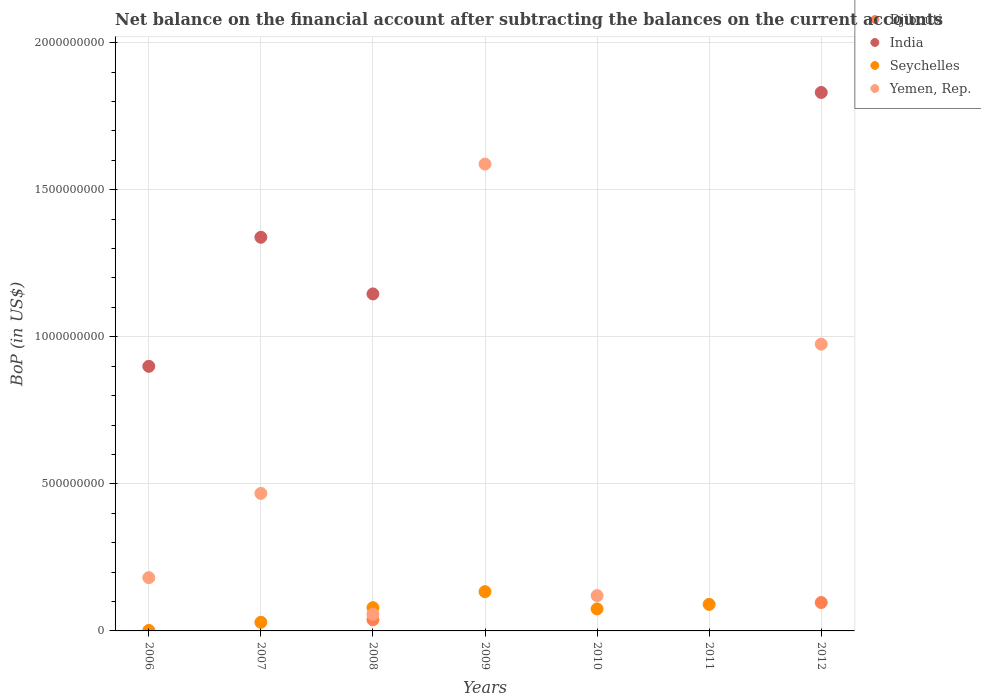What is the Balance of Payments in Djibouti in 2012?
Your answer should be compact. 9.65e+07. Across all years, what is the maximum Balance of Payments in Seychelles?
Your response must be concise. 1.33e+08. Across all years, what is the minimum Balance of Payments in Seychelles?
Your answer should be very brief. 0. What is the total Balance of Payments in India in the graph?
Ensure brevity in your answer.  5.21e+09. What is the difference between the Balance of Payments in Seychelles in 2009 and that in 2011?
Your response must be concise. 4.33e+07. What is the difference between the Balance of Payments in Yemen, Rep. in 2006 and the Balance of Payments in Djibouti in 2007?
Ensure brevity in your answer.  1.81e+08. What is the average Balance of Payments in Djibouti per year?
Give a very brief answer. 1.92e+07. In the year 2009, what is the difference between the Balance of Payments in Seychelles and Balance of Payments in Yemen, Rep.?
Ensure brevity in your answer.  -1.45e+09. In how many years, is the Balance of Payments in Djibouti greater than 100000000 US$?
Make the answer very short. 0. What is the ratio of the Balance of Payments in Seychelles in 2006 to that in 2007?
Offer a terse response. 0.05. Is the difference between the Balance of Payments in Seychelles in 2006 and 2009 greater than the difference between the Balance of Payments in Yemen, Rep. in 2006 and 2009?
Keep it short and to the point. Yes. What is the difference between the highest and the second highest Balance of Payments in Yemen, Rep.?
Ensure brevity in your answer.  6.12e+08. What is the difference between the highest and the lowest Balance of Payments in Seychelles?
Offer a terse response. 1.33e+08. Is it the case that in every year, the sum of the Balance of Payments in Seychelles and Balance of Payments in India  is greater than the Balance of Payments in Djibouti?
Your answer should be very brief. Yes. Is the Balance of Payments in Djibouti strictly less than the Balance of Payments in Seychelles over the years?
Offer a terse response. No. How many dotlines are there?
Provide a short and direct response. 4. What is the difference between two consecutive major ticks on the Y-axis?
Make the answer very short. 5.00e+08. Does the graph contain grids?
Your answer should be compact. Yes. Where does the legend appear in the graph?
Offer a very short reply. Top right. What is the title of the graph?
Ensure brevity in your answer.  Net balance on the financial account after subtracting the balances on the current accounts. What is the label or title of the X-axis?
Ensure brevity in your answer.  Years. What is the label or title of the Y-axis?
Keep it short and to the point. BoP (in US$). What is the BoP (in US$) in India in 2006?
Your answer should be very brief. 9.00e+08. What is the BoP (in US$) in Seychelles in 2006?
Offer a terse response. 1.60e+06. What is the BoP (in US$) of Yemen, Rep. in 2006?
Your answer should be very brief. 1.81e+08. What is the BoP (in US$) of Djibouti in 2007?
Provide a short and direct response. 0. What is the BoP (in US$) of India in 2007?
Your answer should be compact. 1.34e+09. What is the BoP (in US$) of Seychelles in 2007?
Provide a short and direct response. 2.93e+07. What is the BoP (in US$) of Yemen, Rep. in 2007?
Provide a short and direct response. 4.68e+08. What is the BoP (in US$) in Djibouti in 2008?
Your answer should be very brief. 3.79e+07. What is the BoP (in US$) in India in 2008?
Your answer should be compact. 1.15e+09. What is the BoP (in US$) of Seychelles in 2008?
Make the answer very short. 7.90e+07. What is the BoP (in US$) in Yemen, Rep. in 2008?
Make the answer very short. 5.66e+07. What is the BoP (in US$) of India in 2009?
Offer a very short reply. 0. What is the BoP (in US$) of Seychelles in 2009?
Provide a short and direct response. 1.33e+08. What is the BoP (in US$) in Yemen, Rep. in 2009?
Your answer should be very brief. 1.59e+09. What is the BoP (in US$) of India in 2010?
Keep it short and to the point. 0. What is the BoP (in US$) of Seychelles in 2010?
Provide a succinct answer. 7.48e+07. What is the BoP (in US$) in Yemen, Rep. in 2010?
Provide a succinct answer. 1.20e+08. What is the BoP (in US$) of Djibouti in 2011?
Keep it short and to the point. 0. What is the BoP (in US$) of Seychelles in 2011?
Make the answer very short. 9.02e+07. What is the BoP (in US$) of Djibouti in 2012?
Make the answer very short. 9.65e+07. What is the BoP (in US$) of India in 2012?
Ensure brevity in your answer.  1.83e+09. What is the BoP (in US$) of Seychelles in 2012?
Ensure brevity in your answer.  0. What is the BoP (in US$) of Yemen, Rep. in 2012?
Give a very brief answer. 9.75e+08. Across all years, what is the maximum BoP (in US$) of Djibouti?
Keep it short and to the point. 9.65e+07. Across all years, what is the maximum BoP (in US$) in India?
Keep it short and to the point. 1.83e+09. Across all years, what is the maximum BoP (in US$) of Seychelles?
Give a very brief answer. 1.33e+08. Across all years, what is the maximum BoP (in US$) in Yemen, Rep.?
Ensure brevity in your answer.  1.59e+09. Across all years, what is the minimum BoP (in US$) in India?
Provide a succinct answer. 0. Across all years, what is the minimum BoP (in US$) in Yemen, Rep.?
Offer a very short reply. 0. What is the total BoP (in US$) in Djibouti in the graph?
Your answer should be very brief. 1.34e+08. What is the total BoP (in US$) in India in the graph?
Offer a very short reply. 5.21e+09. What is the total BoP (in US$) of Seychelles in the graph?
Provide a succinct answer. 4.08e+08. What is the total BoP (in US$) in Yemen, Rep. in the graph?
Offer a terse response. 3.39e+09. What is the difference between the BoP (in US$) in India in 2006 and that in 2007?
Keep it short and to the point. -4.39e+08. What is the difference between the BoP (in US$) of Seychelles in 2006 and that in 2007?
Provide a short and direct response. -2.77e+07. What is the difference between the BoP (in US$) of Yemen, Rep. in 2006 and that in 2007?
Your response must be concise. -2.86e+08. What is the difference between the BoP (in US$) of India in 2006 and that in 2008?
Give a very brief answer. -2.46e+08. What is the difference between the BoP (in US$) in Seychelles in 2006 and that in 2008?
Provide a short and direct response. -7.74e+07. What is the difference between the BoP (in US$) in Yemen, Rep. in 2006 and that in 2008?
Provide a succinct answer. 1.24e+08. What is the difference between the BoP (in US$) in Seychelles in 2006 and that in 2009?
Your response must be concise. -1.32e+08. What is the difference between the BoP (in US$) of Yemen, Rep. in 2006 and that in 2009?
Your answer should be very brief. -1.41e+09. What is the difference between the BoP (in US$) in Seychelles in 2006 and that in 2010?
Your response must be concise. -7.32e+07. What is the difference between the BoP (in US$) in Yemen, Rep. in 2006 and that in 2010?
Offer a very short reply. 6.11e+07. What is the difference between the BoP (in US$) in Seychelles in 2006 and that in 2011?
Provide a short and direct response. -8.86e+07. What is the difference between the BoP (in US$) in India in 2006 and that in 2012?
Your answer should be very brief. -9.31e+08. What is the difference between the BoP (in US$) in Yemen, Rep. in 2006 and that in 2012?
Make the answer very short. -7.94e+08. What is the difference between the BoP (in US$) of India in 2007 and that in 2008?
Offer a terse response. 1.93e+08. What is the difference between the BoP (in US$) of Seychelles in 2007 and that in 2008?
Provide a succinct answer. -4.97e+07. What is the difference between the BoP (in US$) of Yemen, Rep. in 2007 and that in 2008?
Your response must be concise. 4.11e+08. What is the difference between the BoP (in US$) of Seychelles in 2007 and that in 2009?
Offer a terse response. -1.04e+08. What is the difference between the BoP (in US$) in Yemen, Rep. in 2007 and that in 2009?
Your answer should be very brief. -1.12e+09. What is the difference between the BoP (in US$) in Seychelles in 2007 and that in 2010?
Give a very brief answer. -4.55e+07. What is the difference between the BoP (in US$) in Yemen, Rep. in 2007 and that in 2010?
Offer a very short reply. 3.48e+08. What is the difference between the BoP (in US$) in Seychelles in 2007 and that in 2011?
Offer a terse response. -6.08e+07. What is the difference between the BoP (in US$) of India in 2007 and that in 2012?
Your answer should be very brief. -4.92e+08. What is the difference between the BoP (in US$) in Yemen, Rep. in 2007 and that in 2012?
Provide a short and direct response. -5.07e+08. What is the difference between the BoP (in US$) of Seychelles in 2008 and that in 2009?
Make the answer very short. -5.45e+07. What is the difference between the BoP (in US$) of Yemen, Rep. in 2008 and that in 2009?
Your answer should be compact. -1.53e+09. What is the difference between the BoP (in US$) of Seychelles in 2008 and that in 2010?
Offer a terse response. 4.17e+06. What is the difference between the BoP (in US$) of Yemen, Rep. in 2008 and that in 2010?
Ensure brevity in your answer.  -6.33e+07. What is the difference between the BoP (in US$) in Seychelles in 2008 and that in 2011?
Your answer should be compact. -1.12e+07. What is the difference between the BoP (in US$) in Djibouti in 2008 and that in 2012?
Keep it short and to the point. -5.86e+07. What is the difference between the BoP (in US$) in India in 2008 and that in 2012?
Ensure brevity in your answer.  -6.85e+08. What is the difference between the BoP (in US$) of Yemen, Rep. in 2008 and that in 2012?
Your answer should be very brief. -9.18e+08. What is the difference between the BoP (in US$) in Seychelles in 2009 and that in 2010?
Offer a terse response. 5.86e+07. What is the difference between the BoP (in US$) in Yemen, Rep. in 2009 and that in 2010?
Your response must be concise. 1.47e+09. What is the difference between the BoP (in US$) in Seychelles in 2009 and that in 2011?
Your answer should be compact. 4.33e+07. What is the difference between the BoP (in US$) in Yemen, Rep. in 2009 and that in 2012?
Provide a short and direct response. 6.12e+08. What is the difference between the BoP (in US$) of Seychelles in 2010 and that in 2011?
Give a very brief answer. -1.54e+07. What is the difference between the BoP (in US$) in Yemen, Rep. in 2010 and that in 2012?
Ensure brevity in your answer.  -8.55e+08. What is the difference between the BoP (in US$) of India in 2006 and the BoP (in US$) of Seychelles in 2007?
Provide a succinct answer. 8.70e+08. What is the difference between the BoP (in US$) of India in 2006 and the BoP (in US$) of Yemen, Rep. in 2007?
Your answer should be compact. 4.32e+08. What is the difference between the BoP (in US$) of Seychelles in 2006 and the BoP (in US$) of Yemen, Rep. in 2007?
Your answer should be compact. -4.66e+08. What is the difference between the BoP (in US$) in India in 2006 and the BoP (in US$) in Seychelles in 2008?
Give a very brief answer. 8.21e+08. What is the difference between the BoP (in US$) of India in 2006 and the BoP (in US$) of Yemen, Rep. in 2008?
Offer a terse response. 8.43e+08. What is the difference between the BoP (in US$) in Seychelles in 2006 and the BoP (in US$) in Yemen, Rep. in 2008?
Ensure brevity in your answer.  -5.50e+07. What is the difference between the BoP (in US$) of India in 2006 and the BoP (in US$) of Seychelles in 2009?
Your response must be concise. 7.66e+08. What is the difference between the BoP (in US$) in India in 2006 and the BoP (in US$) in Yemen, Rep. in 2009?
Offer a very short reply. -6.88e+08. What is the difference between the BoP (in US$) of Seychelles in 2006 and the BoP (in US$) of Yemen, Rep. in 2009?
Offer a very short reply. -1.59e+09. What is the difference between the BoP (in US$) in India in 2006 and the BoP (in US$) in Seychelles in 2010?
Provide a short and direct response. 8.25e+08. What is the difference between the BoP (in US$) of India in 2006 and the BoP (in US$) of Yemen, Rep. in 2010?
Give a very brief answer. 7.80e+08. What is the difference between the BoP (in US$) of Seychelles in 2006 and the BoP (in US$) of Yemen, Rep. in 2010?
Your answer should be very brief. -1.18e+08. What is the difference between the BoP (in US$) in India in 2006 and the BoP (in US$) in Seychelles in 2011?
Make the answer very short. 8.09e+08. What is the difference between the BoP (in US$) of India in 2006 and the BoP (in US$) of Yemen, Rep. in 2012?
Offer a very short reply. -7.53e+07. What is the difference between the BoP (in US$) in Seychelles in 2006 and the BoP (in US$) in Yemen, Rep. in 2012?
Your answer should be compact. -9.73e+08. What is the difference between the BoP (in US$) in India in 2007 and the BoP (in US$) in Seychelles in 2008?
Provide a succinct answer. 1.26e+09. What is the difference between the BoP (in US$) in India in 2007 and the BoP (in US$) in Yemen, Rep. in 2008?
Ensure brevity in your answer.  1.28e+09. What is the difference between the BoP (in US$) in Seychelles in 2007 and the BoP (in US$) in Yemen, Rep. in 2008?
Keep it short and to the point. -2.73e+07. What is the difference between the BoP (in US$) in India in 2007 and the BoP (in US$) in Seychelles in 2009?
Offer a very short reply. 1.20e+09. What is the difference between the BoP (in US$) in India in 2007 and the BoP (in US$) in Yemen, Rep. in 2009?
Your response must be concise. -2.49e+08. What is the difference between the BoP (in US$) of Seychelles in 2007 and the BoP (in US$) of Yemen, Rep. in 2009?
Your answer should be very brief. -1.56e+09. What is the difference between the BoP (in US$) of India in 2007 and the BoP (in US$) of Seychelles in 2010?
Your response must be concise. 1.26e+09. What is the difference between the BoP (in US$) in India in 2007 and the BoP (in US$) in Yemen, Rep. in 2010?
Offer a terse response. 1.22e+09. What is the difference between the BoP (in US$) in Seychelles in 2007 and the BoP (in US$) in Yemen, Rep. in 2010?
Offer a very short reply. -9.06e+07. What is the difference between the BoP (in US$) of India in 2007 and the BoP (in US$) of Seychelles in 2011?
Ensure brevity in your answer.  1.25e+09. What is the difference between the BoP (in US$) of India in 2007 and the BoP (in US$) of Yemen, Rep. in 2012?
Your response must be concise. 3.63e+08. What is the difference between the BoP (in US$) of Seychelles in 2007 and the BoP (in US$) of Yemen, Rep. in 2012?
Your response must be concise. -9.46e+08. What is the difference between the BoP (in US$) of Djibouti in 2008 and the BoP (in US$) of Seychelles in 2009?
Ensure brevity in your answer.  -9.56e+07. What is the difference between the BoP (in US$) of Djibouti in 2008 and the BoP (in US$) of Yemen, Rep. in 2009?
Offer a terse response. -1.55e+09. What is the difference between the BoP (in US$) in India in 2008 and the BoP (in US$) in Seychelles in 2009?
Offer a very short reply. 1.01e+09. What is the difference between the BoP (in US$) of India in 2008 and the BoP (in US$) of Yemen, Rep. in 2009?
Your answer should be compact. -4.42e+08. What is the difference between the BoP (in US$) in Seychelles in 2008 and the BoP (in US$) in Yemen, Rep. in 2009?
Offer a very short reply. -1.51e+09. What is the difference between the BoP (in US$) of Djibouti in 2008 and the BoP (in US$) of Seychelles in 2010?
Your answer should be compact. -3.69e+07. What is the difference between the BoP (in US$) of Djibouti in 2008 and the BoP (in US$) of Yemen, Rep. in 2010?
Offer a terse response. -8.21e+07. What is the difference between the BoP (in US$) of India in 2008 and the BoP (in US$) of Seychelles in 2010?
Provide a succinct answer. 1.07e+09. What is the difference between the BoP (in US$) of India in 2008 and the BoP (in US$) of Yemen, Rep. in 2010?
Ensure brevity in your answer.  1.03e+09. What is the difference between the BoP (in US$) of Seychelles in 2008 and the BoP (in US$) of Yemen, Rep. in 2010?
Offer a very short reply. -4.10e+07. What is the difference between the BoP (in US$) of Djibouti in 2008 and the BoP (in US$) of Seychelles in 2011?
Provide a short and direct response. -5.23e+07. What is the difference between the BoP (in US$) of India in 2008 and the BoP (in US$) of Seychelles in 2011?
Your answer should be compact. 1.06e+09. What is the difference between the BoP (in US$) in Djibouti in 2008 and the BoP (in US$) in India in 2012?
Make the answer very short. -1.79e+09. What is the difference between the BoP (in US$) in Djibouti in 2008 and the BoP (in US$) in Yemen, Rep. in 2012?
Offer a terse response. -9.37e+08. What is the difference between the BoP (in US$) of India in 2008 and the BoP (in US$) of Yemen, Rep. in 2012?
Your response must be concise. 1.71e+08. What is the difference between the BoP (in US$) of Seychelles in 2008 and the BoP (in US$) of Yemen, Rep. in 2012?
Ensure brevity in your answer.  -8.96e+08. What is the difference between the BoP (in US$) in Seychelles in 2009 and the BoP (in US$) in Yemen, Rep. in 2010?
Offer a very short reply. 1.35e+07. What is the difference between the BoP (in US$) of Seychelles in 2009 and the BoP (in US$) of Yemen, Rep. in 2012?
Your answer should be very brief. -8.42e+08. What is the difference between the BoP (in US$) in Seychelles in 2010 and the BoP (in US$) in Yemen, Rep. in 2012?
Offer a terse response. -9.00e+08. What is the difference between the BoP (in US$) of Seychelles in 2011 and the BoP (in US$) of Yemen, Rep. in 2012?
Keep it short and to the point. -8.85e+08. What is the average BoP (in US$) in Djibouti per year?
Offer a terse response. 1.92e+07. What is the average BoP (in US$) in India per year?
Your answer should be compact. 7.45e+08. What is the average BoP (in US$) of Seychelles per year?
Offer a very short reply. 5.83e+07. What is the average BoP (in US$) of Yemen, Rep. per year?
Ensure brevity in your answer.  4.84e+08. In the year 2006, what is the difference between the BoP (in US$) of India and BoP (in US$) of Seychelles?
Your response must be concise. 8.98e+08. In the year 2006, what is the difference between the BoP (in US$) of India and BoP (in US$) of Yemen, Rep.?
Provide a succinct answer. 7.19e+08. In the year 2006, what is the difference between the BoP (in US$) of Seychelles and BoP (in US$) of Yemen, Rep.?
Provide a succinct answer. -1.79e+08. In the year 2007, what is the difference between the BoP (in US$) in India and BoP (in US$) in Seychelles?
Ensure brevity in your answer.  1.31e+09. In the year 2007, what is the difference between the BoP (in US$) of India and BoP (in US$) of Yemen, Rep.?
Your response must be concise. 8.71e+08. In the year 2007, what is the difference between the BoP (in US$) in Seychelles and BoP (in US$) in Yemen, Rep.?
Your answer should be very brief. -4.38e+08. In the year 2008, what is the difference between the BoP (in US$) of Djibouti and BoP (in US$) of India?
Give a very brief answer. -1.11e+09. In the year 2008, what is the difference between the BoP (in US$) of Djibouti and BoP (in US$) of Seychelles?
Your response must be concise. -4.11e+07. In the year 2008, what is the difference between the BoP (in US$) of Djibouti and BoP (in US$) of Yemen, Rep.?
Your answer should be very brief. -1.87e+07. In the year 2008, what is the difference between the BoP (in US$) in India and BoP (in US$) in Seychelles?
Your answer should be compact. 1.07e+09. In the year 2008, what is the difference between the BoP (in US$) in India and BoP (in US$) in Yemen, Rep.?
Your answer should be very brief. 1.09e+09. In the year 2008, what is the difference between the BoP (in US$) in Seychelles and BoP (in US$) in Yemen, Rep.?
Your response must be concise. 2.23e+07. In the year 2009, what is the difference between the BoP (in US$) of Seychelles and BoP (in US$) of Yemen, Rep.?
Keep it short and to the point. -1.45e+09. In the year 2010, what is the difference between the BoP (in US$) of Seychelles and BoP (in US$) of Yemen, Rep.?
Your answer should be very brief. -4.52e+07. In the year 2012, what is the difference between the BoP (in US$) of Djibouti and BoP (in US$) of India?
Give a very brief answer. -1.73e+09. In the year 2012, what is the difference between the BoP (in US$) in Djibouti and BoP (in US$) in Yemen, Rep.?
Your answer should be very brief. -8.78e+08. In the year 2012, what is the difference between the BoP (in US$) in India and BoP (in US$) in Yemen, Rep.?
Offer a very short reply. 8.56e+08. What is the ratio of the BoP (in US$) of India in 2006 to that in 2007?
Make the answer very short. 0.67. What is the ratio of the BoP (in US$) in Seychelles in 2006 to that in 2007?
Offer a very short reply. 0.05. What is the ratio of the BoP (in US$) in Yemen, Rep. in 2006 to that in 2007?
Offer a very short reply. 0.39. What is the ratio of the BoP (in US$) in India in 2006 to that in 2008?
Provide a short and direct response. 0.79. What is the ratio of the BoP (in US$) in Seychelles in 2006 to that in 2008?
Your answer should be compact. 0.02. What is the ratio of the BoP (in US$) in Yemen, Rep. in 2006 to that in 2008?
Your response must be concise. 3.2. What is the ratio of the BoP (in US$) in Seychelles in 2006 to that in 2009?
Provide a short and direct response. 0.01. What is the ratio of the BoP (in US$) of Yemen, Rep. in 2006 to that in 2009?
Offer a very short reply. 0.11. What is the ratio of the BoP (in US$) in Seychelles in 2006 to that in 2010?
Your answer should be very brief. 0.02. What is the ratio of the BoP (in US$) of Yemen, Rep. in 2006 to that in 2010?
Offer a very short reply. 1.51. What is the ratio of the BoP (in US$) of Seychelles in 2006 to that in 2011?
Provide a short and direct response. 0.02. What is the ratio of the BoP (in US$) of India in 2006 to that in 2012?
Keep it short and to the point. 0.49. What is the ratio of the BoP (in US$) of Yemen, Rep. in 2006 to that in 2012?
Ensure brevity in your answer.  0.19. What is the ratio of the BoP (in US$) of India in 2007 to that in 2008?
Offer a terse response. 1.17. What is the ratio of the BoP (in US$) in Seychelles in 2007 to that in 2008?
Offer a terse response. 0.37. What is the ratio of the BoP (in US$) of Yemen, Rep. in 2007 to that in 2008?
Keep it short and to the point. 8.26. What is the ratio of the BoP (in US$) in Seychelles in 2007 to that in 2009?
Keep it short and to the point. 0.22. What is the ratio of the BoP (in US$) in Yemen, Rep. in 2007 to that in 2009?
Provide a short and direct response. 0.29. What is the ratio of the BoP (in US$) of Seychelles in 2007 to that in 2010?
Your response must be concise. 0.39. What is the ratio of the BoP (in US$) in Yemen, Rep. in 2007 to that in 2010?
Keep it short and to the point. 3.9. What is the ratio of the BoP (in US$) of Seychelles in 2007 to that in 2011?
Your answer should be compact. 0.33. What is the ratio of the BoP (in US$) of India in 2007 to that in 2012?
Keep it short and to the point. 0.73. What is the ratio of the BoP (in US$) of Yemen, Rep. in 2007 to that in 2012?
Provide a succinct answer. 0.48. What is the ratio of the BoP (in US$) of Seychelles in 2008 to that in 2009?
Provide a short and direct response. 0.59. What is the ratio of the BoP (in US$) of Yemen, Rep. in 2008 to that in 2009?
Provide a short and direct response. 0.04. What is the ratio of the BoP (in US$) in Seychelles in 2008 to that in 2010?
Ensure brevity in your answer.  1.06. What is the ratio of the BoP (in US$) in Yemen, Rep. in 2008 to that in 2010?
Your answer should be very brief. 0.47. What is the ratio of the BoP (in US$) of Seychelles in 2008 to that in 2011?
Keep it short and to the point. 0.88. What is the ratio of the BoP (in US$) of Djibouti in 2008 to that in 2012?
Your answer should be compact. 0.39. What is the ratio of the BoP (in US$) in India in 2008 to that in 2012?
Provide a succinct answer. 0.63. What is the ratio of the BoP (in US$) in Yemen, Rep. in 2008 to that in 2012?
Provide a succinct answer. 0.06. What is the ratio of the BoP (in US$) of Seychelles in 2009 to that in 2010?
Give a very brief answer. 1.78. What is the ratio of the BoP (in US$) of Yemen, Rep. in 2009 to that in 2010?
Make the answer very short. 13.23. What is the ratio of the BoP (in US$) in Seychelles in 2009 to that in 2011?
Offer a terse response. 1.48. What is the ratio of the BoP (in US$) in Yemen, Rep. in 2009 to that in 2012?
Give a very brief answer. 1.63. What is the ratio of the BoP (in US$) in Seychelles in 2010 to that in 2011?
Offer a terse response. 0.83. What is the ratio of the BoP (in US$) in Yemen, Rep. in 2010 to that in 2012?
Offer a terse response. 0.12. What is the difference between the highest and the second highest BoP (in US$) in India?
Provide a succinct answer. 4.92e+08. What is the difference between the highest and the second highest BoP (in US$) of Seychelles?
Offer a terse response. 4.33e+07. What is the difference between the highest and the second highest BoP (in US$) of Yemen, Rep.?
Provide a short and direct response. 6.12e+08. What is the difference between the highest and the lowest BoP (in US$) in Djibouti?
Your answer should be very brief. 9.65e+07. What is the difference between the highest and the lowest BoP (in US$) of India?
Give a very brief answer. 1.83e+09. What is the difference between the highest and the lowest BoP (in US$) of Seychelles?
Your answer should be compact. 1.33e+08. What is the difference between the highest and the lowest BoP (in US$) of Yemen, Rep.?
Provide a succinct answer. 1.59e+09. 